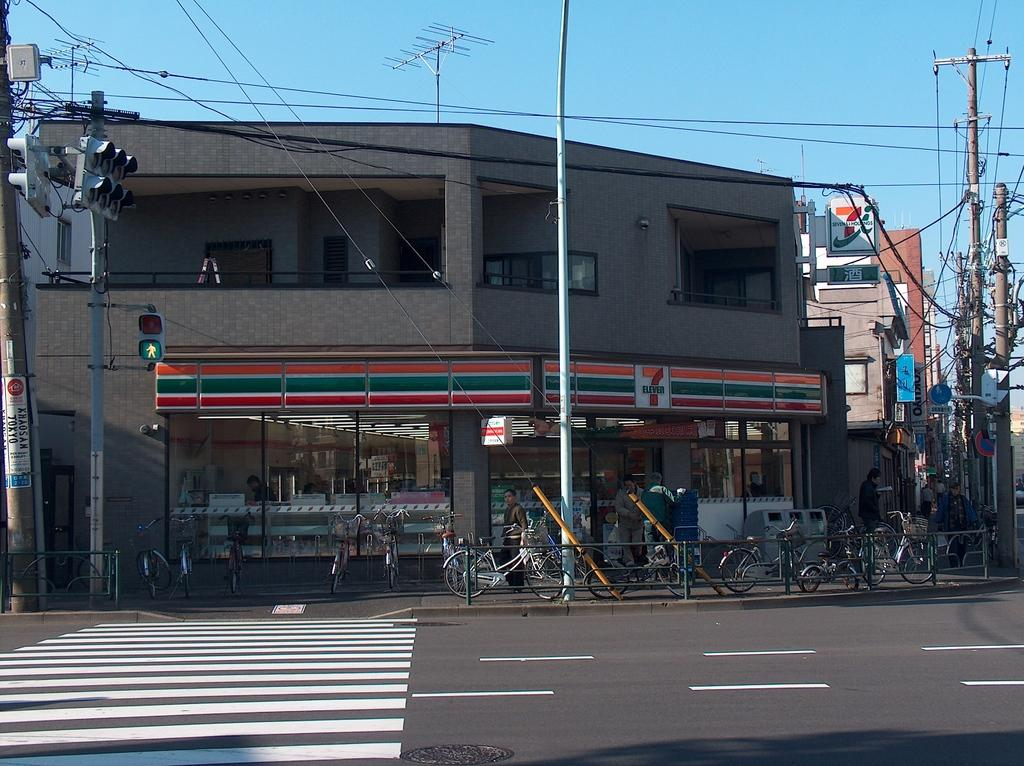<image>
Describe the image concisely. The storefront of a 7 Eleven  with some bicycles in front of it. 